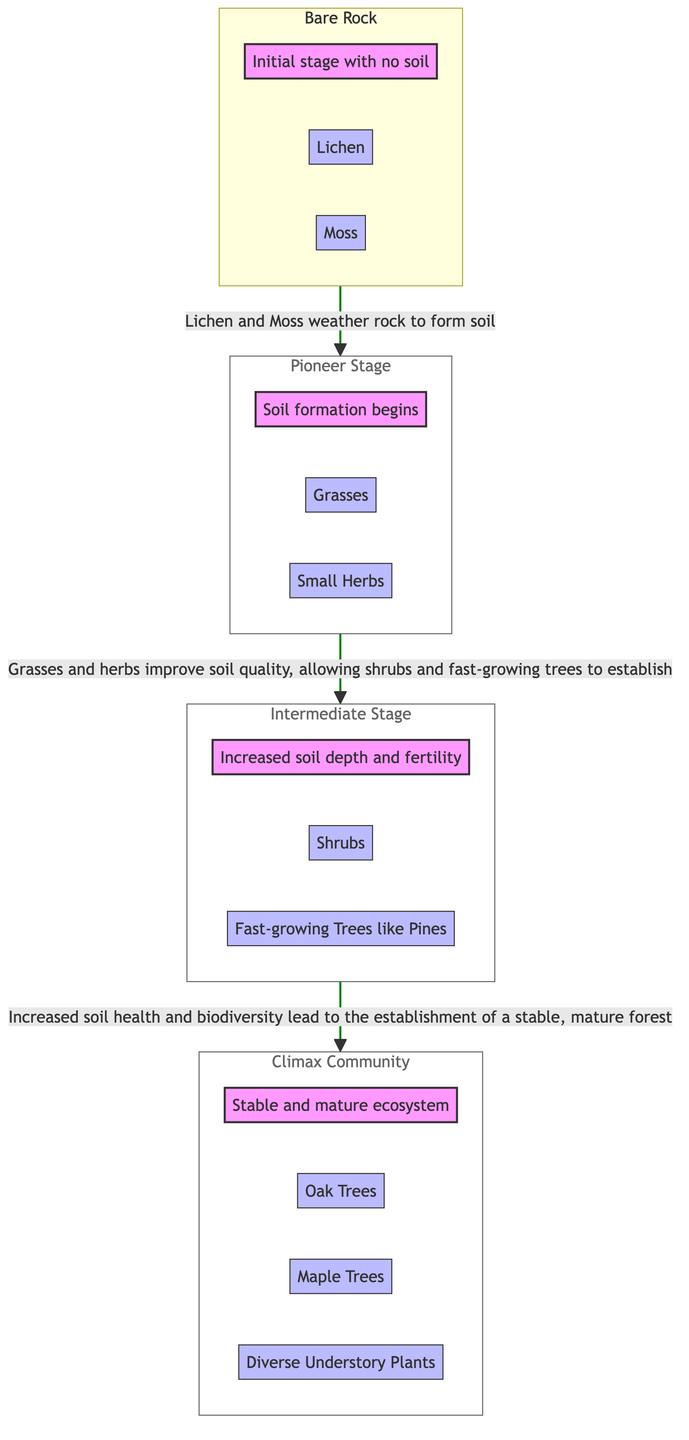What is the initial stage of ecological succession? The diagram states the initial stage is "Bare Rock," which signifies an environment with no soil present, marking the starting point for ecological succession.
Answer: Bare Rock What species are prevalent in the Pioneer Stage? The diagram identifies "Grasses" and "Small Herbs" as the primary species present during the Pioneer Stage, highlighting the initial plant life that grows once soil begins to form.
Answer: Grasses and Small Herbs What is the main process that occurs between Stage 1 and Stage 2? The interaction describes that "Lichen and Moss weather rock to form soil," indicating that these pioneer organisms are essential in starting soil formation for subsequent stages.
Answer: Weathering of rock How many species are listed in the Climax Community? In the Climax Community section, there are four distinct species mentioned: "Oak Trees," "Maple Trees," and "Diverse Understory Plants," totaling three species.
Answer: Three species What leads to the establishment of the Climax Community? The transition to the Climax Community is described as resulting from "Increased soil health and biodiversity," indicating that improved conditions allow for a stable, mature forest to form.
Answer: Increased soil health and biodiversity What is an important factor that improves soil quality in Stage 2? The transition from the Pioneer Stage to the Intermediate Stage indicates that "Grasses and herbs improve soil quality," suggesting that their growth enhances the soil, facilitating the establishment of more complex plants.
Answer: Grasses and herbs What type of ecosystem is formed in the Climax Community? According to the diagram, the Climax Community is described as a "Stable and mature ecosystem," indicating the final and most stable stage in ecological succession.
Answer: Stable and mature ecosystem How does soil depth change throughout the succession process? The diagram shows that in the Intermediate Stage, "Increased soil depth and fertility" occurs, implying that as succession progresses, the soil becomes deeper and more fertile, supporting more plant life.
Answer: Increased soil depth and fertility What environmental condition is primarily addressed in Stage 3? Stage 3, or the Intermediate Stage, focuses on the "Increased soil depth and fertility," which highlights the improvement in soil conditions necessary for further plant growth.
Answer: Increased soil depth and fertility 